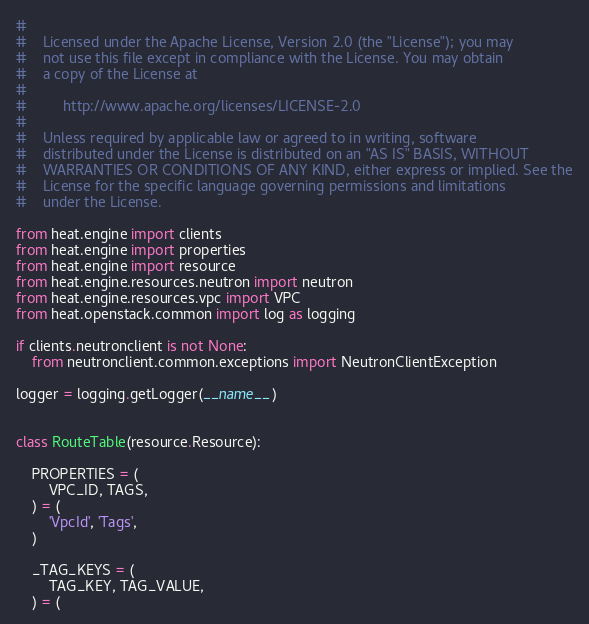<code> <loc_0><loc_0><loc_500><loc_500><_Python_>
#
#    Licensed under the Apache License, Version 2.0 (the "License"); you may
#    not use this file except in compliance with the License. You may obtain
#    a copy of the License at
#
#         http://www.apache.org/licenses/LICENSE-2.0
#
#    Unless required by applicable law or agreed to in writing, software
#    distributed under the License is distributed on an "AS IS" BASIS, WITHOUT
#    WARRANTIES OR CONDITIONS OF ANY KIND, either express or implied. See the
#    License for the specific language governing permissions and limitations
#    under the License.

from heat.engine import clients
from heat.engine import properties
from heat.engine import resource
from heat.engine.resources.neutron import neutron
from heat.engine.resources.vpc import VPC
from heat.openstack.common import log as logging

if clients.neutronclient is not None:
    from neutronclient.common.exceptions import NeutronClientException

logger = logging.getLogger(__name__)


class RouteTable(resource.Resource):

    PROPERTIES = (
        VPC_ID, TAGS,
    ) = (
        'VpcId', 'Tags',
    )

    _TAG_KEYS = (
        TAG_KEY, TAG_VALUE,
    ) = (</code> 